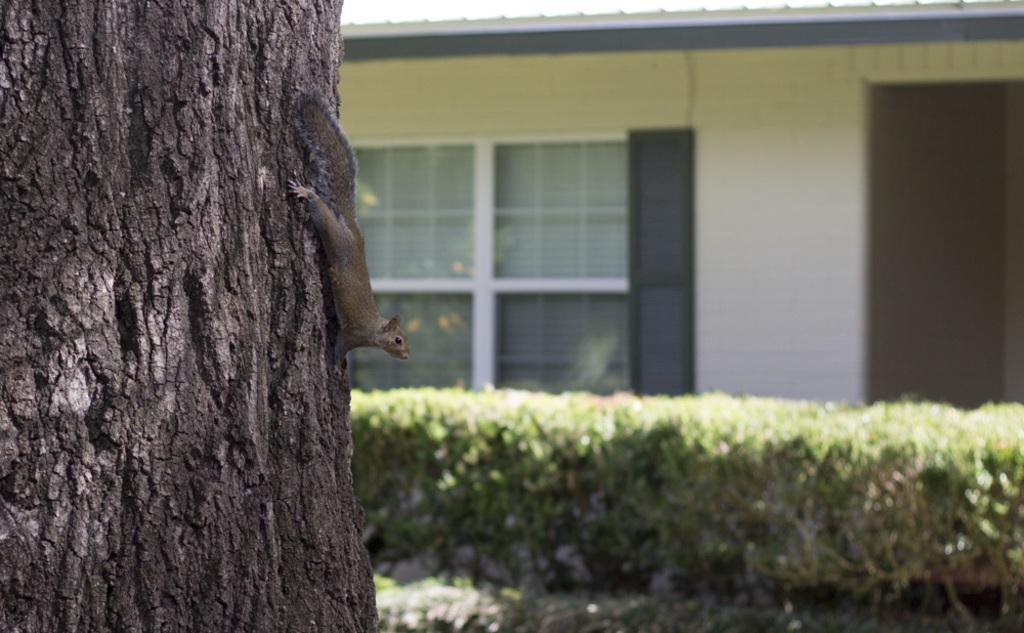What animal can be seen in the image? There is a squirrel in the image. Where is the squirrel located? The squirrel is on a tree trunk. What can be seen in the background of the image? There are plants and a wall in the background of the image. Are there any other objects visible in the background? Yes, there are some objects in the background of the image. What type of pie is the squirrel holding in the image? There is no pie present in the image; the squirrel is on a tree trunk and there are no other objects in its possession. 